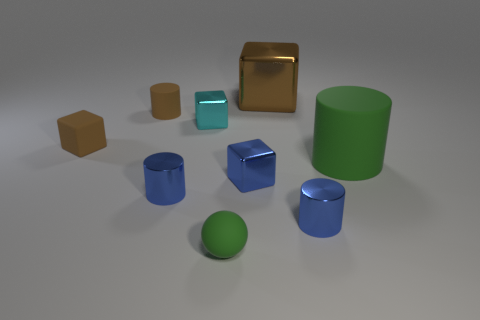Subtract all balls. How many objects are left? 8 Add 8 green rubber spheres. How many green rubber spheres are left? 9 Add 8 red cubes. How many red cubes exist? 8 Subtract 0 cyan cylinders. How many objects are left? 9 Subtract all small blue things. Subtract all blocks. How many objects are left? 2 